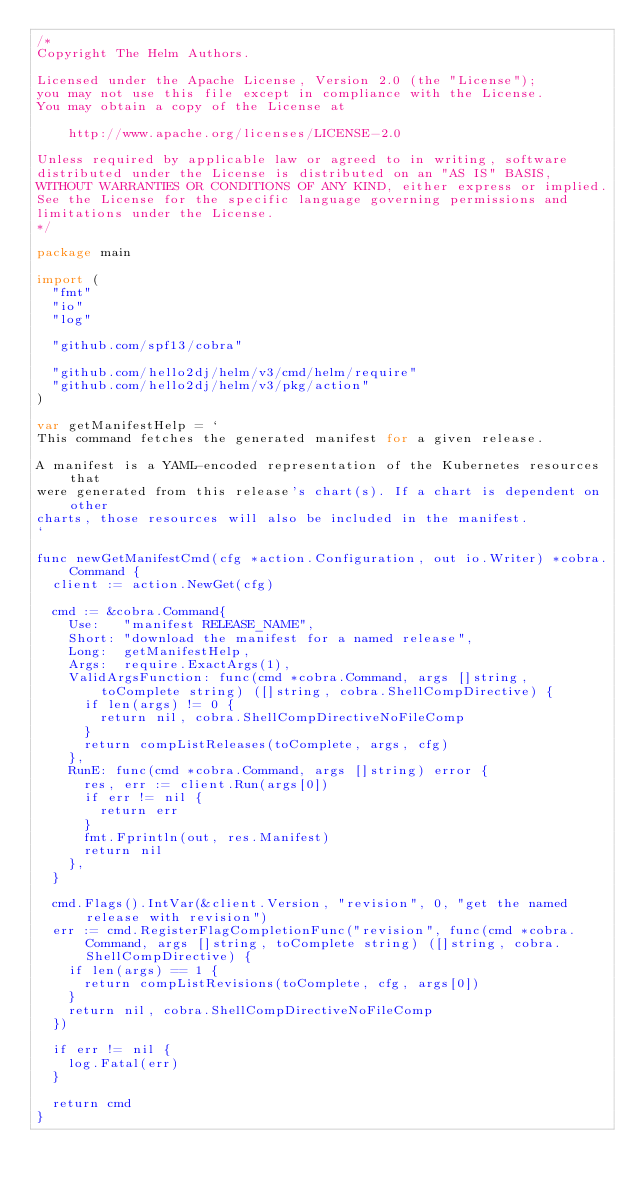<code> <loc_0><loc_0><loc_500><loc_500><_Go_>/*
Copyright The Helm Authors.

Licensed under the Apache License, Version 2.0 (the "License");
you may not use this file except in compliance with the License.
You may obtain a copy of the License at

    http://www.apache.org/licenses/LICENSE-2.0

Unless required by applicable law or agreed to in writing, software
distributed under the License is distributed on an "AS IS" BASIS,
WITHOUT WARRANTIES OR CONDITIONS OF ANY KIND, either express or implied.
See the License for the specific language governing permissions and
limitations under the License.
*/

package main

import (
	"fmt"
	"io"
	"log"

	"github.com/spf13/cobra"

	"github.com/hello2dj/helm/v3/cmd/helm/require"
	"github.com/hello2dj/helm/v3/pkg/action"
)

var getManifestHelp = `
This command fetches the generated manifest for a given release.

A manifest is a YAML-encoded representation of the Kubernetes resources that
were generated from this release's chart(s). If a chart is dependent on other
charts, those resources will also be included in the manifest.
`

func newGetManifestCmd(cfg *action.Configuration, out io.Writer) *cobra.Command {
	client := action.NewGet(cfg)

	cmd := &cobra.Command{
		Use:   "manifest RELEASE_NAME",
		Short: "download the manifest for a named release",
		Long:  getManifestHelp,
		Args:  require.ExactArgs(1),
		ValidArgsFunction: func(cmd *cobra.Command, args []string, toComplete string) ([]string, cobra.ShellCompDirective) {
			if len(args) != 0 {
				return nil, cobra.ShellCompDirectiveNoFileComp
			}
			return compListReleases(toComplete, args, cfg)
		},
		RunE: func(cmd *cobra.Command, args []string) error {
			res, err := client.Run(args[0])
			if err != nil {
				return err
			}
			fmt.Fprintln(out, res.Manifest)
			return nil
		},
	}

	cmd.Flags().IntVar(&client.Version, "revision", 0, "get the named release with revision")
	err := cmd.RegisterFlagCompletionFunc("revision", func(cmd *cobra.Command, args []string, toComplete string) ([]string, cobra.ShellCompDirective) {
		if len(args) == 1 {
			return compListRevisions(toComplete, cfg, args[0])
		}
		return nil, cobra.ShellCompDirectiveNoFileComp
	})

	if err != nil {
		log.Fatal(err)
	}

	return cmd
}
</code> 